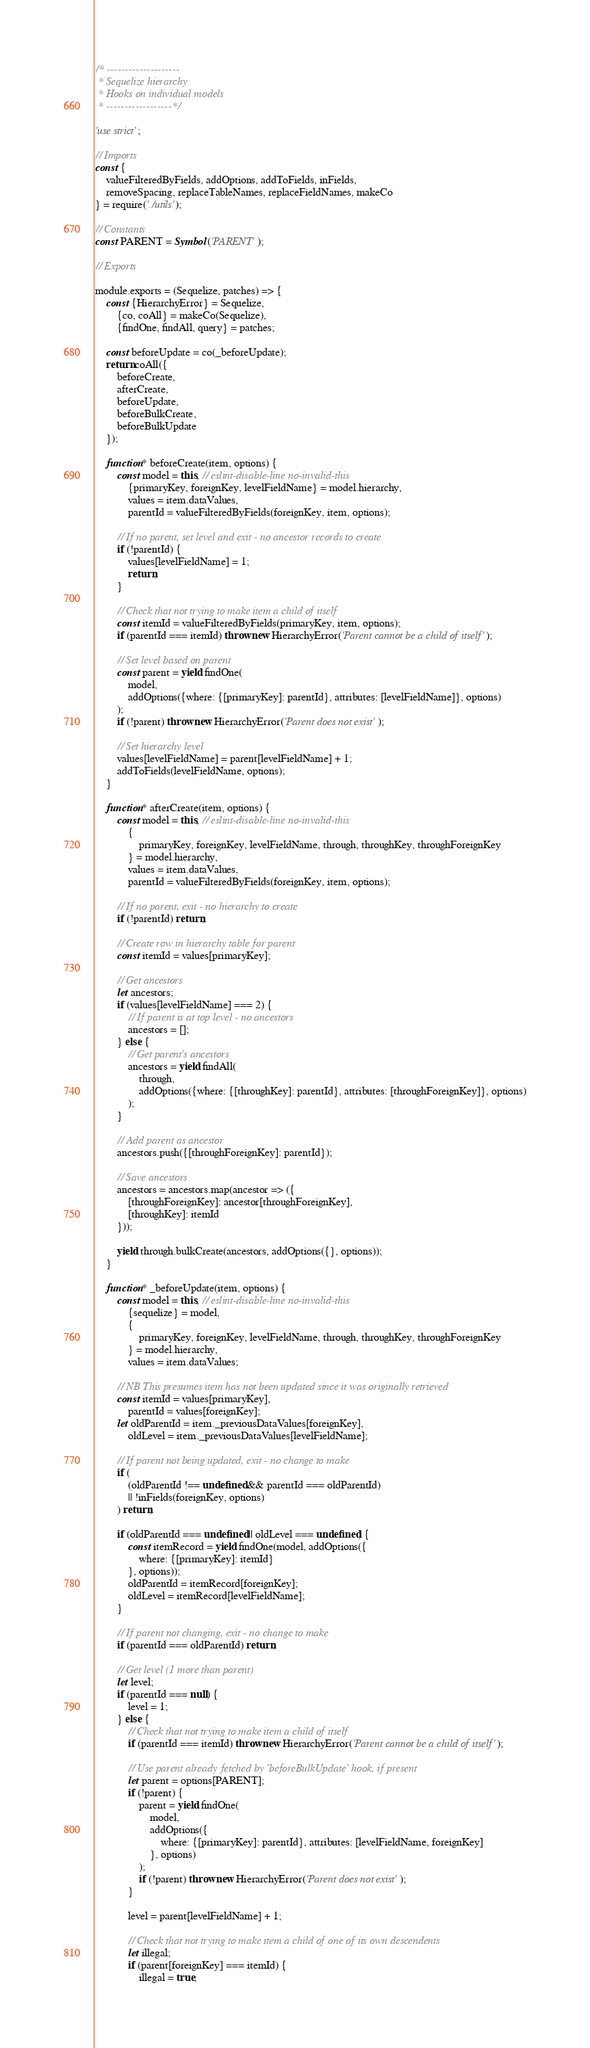<code> <loc_0><loc_0><loc_500><loc_500><_JavaScript_>/* --------------------
 * Sequelize hierarchy
 * Hooks on individual models
 * ------------------*/

'use strict';

// Imports
const {
	valueFilteredByFields, addOptions, addToFields, inFields,
	removeSpacing, replaceTableNames, replaceFieldNames, makeCo
} = require('./utils');

// Constants
const PARENT = Symbol('PARENT');

// Exports

module.exports = (Sequelize, patches) => {
	const {HierarchyError} = Sequelize,
		{co, coAll} = makeCo(Sequelize),
		{findOne, findAll, query} = patches;

	const beforeUpdate = co(_beforeUpdate);
	return coAll({
		beforeCreate,
		afterCreate,
		beforeUpdate,
		beforeBulkCreate,
		beforeBulkUpdate
	});

	function* beforeCreate(item, options) {
		const model = this, // eslint-disable-line no-invalid-this
			{primaryKey, foreignKey, levelFieldName} = model.hierarchy,
			values = item.dataValues,
			parentId = valueFilteredByFields(foreignKey, item, options);

		// If no parent, set level and exit - no ancestor records to create
		if (!parentId) {
			values[levelFieldName] = 1;
			return;
		}

		// Check that not trying to make item a child of itself
		const itemId = valueFilteredByFields(primaryKey, item, options);
		if (parentId === itemId) throw new HierarchyError('Parent cannot be a child of itself');

		// Set level based on parent
		const parent = yield findOne(
			model,
			addOptions({where: {[primaryKey]: parentId}, attributes: [levelFieldName]}, options)
		);
		if (!parent) throw new HierarchyError('Parent does not exist');

		// Set hierarchy level
		values[levelFieldName] = parent[levelFieldName] + 1;
		addToFields(levelFieldName, options);
	}

	function* afterCreate(item, options) {
		const model = this, // eslint-disable-line no-invalid-this
			{
				primaryKey, foreignKey, levelFieldName, through, throughKey, throughForeignKey
			} = model.hierarchy,
			values = item.dataValues,
			parentId = valueFilteredByFields(foreignKey, item, options);

		// If no parent, exit - no hierarchy to create
		if (!parentId) return;

		// Create row in hierarchy table for parent
		const itemId = values[primaryKey];

		// Get ancestors
		let ancestors;
		if (values[levelFieldName] === 2) {
			// If parent is at top level - no ancestors
			ancestors = [];
		} else {
			// Get parent's ancestors
			ancestors = yield findAll(
				through,
				addOptions({where: {[throughKey]: parentId}, attributes: [throughForeignKey]}, options)
			);
		}

		// Add parent as ancestor
		ancestors.push({[throughForeignKey]: parentId});

		// Save ancestors
		ancestors = ancestors.map(ancestor => ({
			[throughForeignKey]: ancestor[throughForeignKey],
			[throughKey]: itemId
		}));

		yield through.bulkCreate(ancestors, addOptions({}, options));
	}

	function* _beforeUpdate(item, options) {
		const model = this, // eslint-disable-line no-invalid-this
			{sequelize} = model,
			{
				primaryKey, foreignKey, levelFieldName, through, throughKey, throughForeignKey
			} = model.hierarchy,
			values = item.dataValues;

		// NB This presumes item has not been updated since it was originally retrieved
		const itemId = values[primaryKey],
			parentId = values[foreignKey];
		let oldParentId = item._previousDataValues[foreignKey],
			oldLevel = item._previousDataValues[levelFieldName];

		// If parent not being updated, exit - no change to make
		if (
			(oldParentId !== undefined && parentId === oldParentId)
			|| !inFields(foreignKey, options)
		) return;

		if (oldParentId === undefined || oldLevel === undefined) {
			const itemRecord = yield findOne(model, addOptions({
				where: {[primaryKey]: itemId}
			}, options));
			oldParentId = itemRecord[foreignKey];
			oldLevel = itemRecord[levelFieldName];
		}

		// If parent not changing, exit - no change to make
		if (parentId === oldParentId) return;

		// Get level (1 more than parent)
		let level;
		if (parentId === null) {
			level = 1;
		} else {
			// Check that not trying to make item a child of itself
			if (parentId === itemId) throw new HierarchyError('Parent cannot be a child of itself');

			// Use parent already fetched by `beforeBulkUpdate` hook, if present
			let parent = options[PARENT];
			if (!parent) {
				parent = yield findOne(
					model,
					addOptions({
						where: {[primaryKey]: parentId}, attributes: [levelFieldName, foreignKey]
					}, options)
				);
				if (!parent) throw new HierarchyError('Parent does not exist');
			}

			level = parent[levelFieldName] + 1;

			// Check that not trying to make item a child of one of its own descendents
			let illegal;
			if (parent[foreignKey] === itemId) {
				illegal = true;</code> 